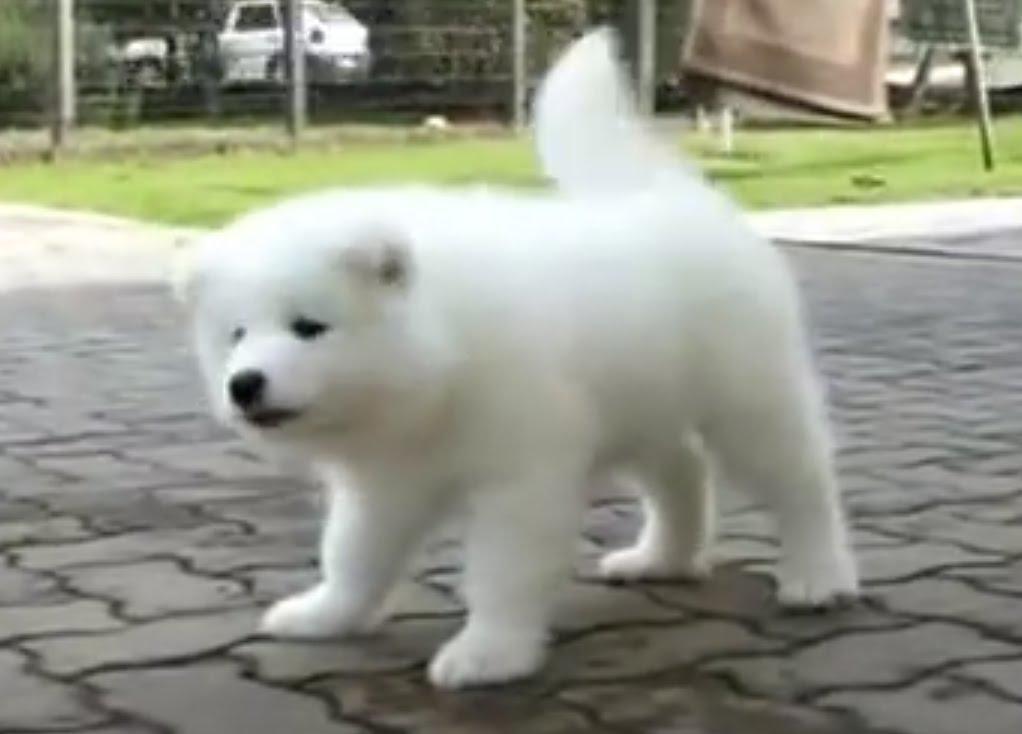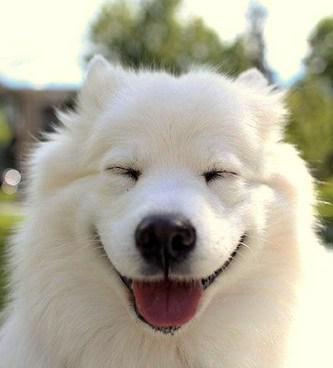The first image is the image on the left, the second image is the image on the right. Analyze the images presented: Is the assertion "There are two white dogs standing on the ground outside." valid? Answer yes or no. No. 